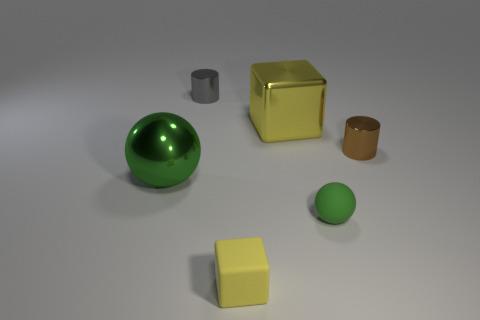Add 1 small gray cylinders. How many objects exist? 7 Subtract all balls. How many objects are left? 4 Add 4 large metallic objects. How many large metallic objects are left? 6 Add 5 green matte balls. How many green matte balls exist? 6 Subtract 0 yellow balls. How many objects are left? 6 Subtract all small yellow matte blocks. Subtract all green metal objects. How many objects are left? 4 